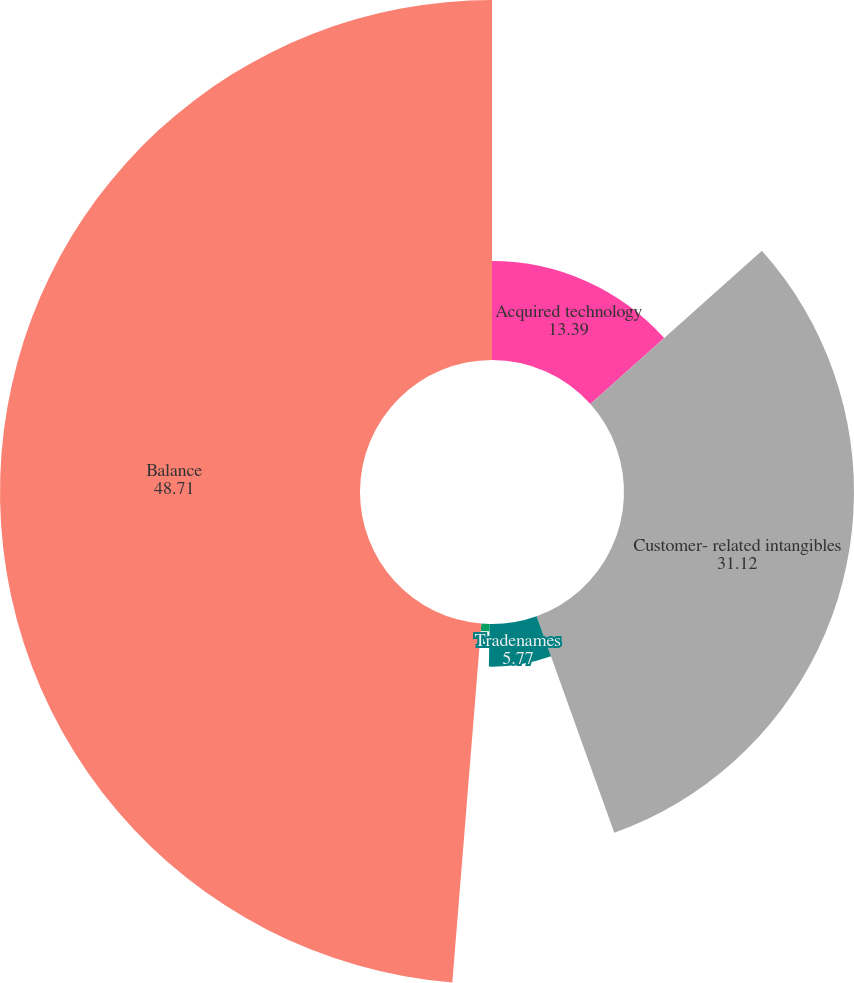Convert chart to OTSL. <chart><loc_0><loc_0><loc_500><loc_500><pie_chart><fcel>Acquired technology<fcel>Customer- related intangibles<fcel>Tradenames<fcel>Other<fcel>Balance<nl><fcel>13.39%<fcel>31.12%<fcel>5.77%<fcel>1.0%<fcel>48.71%<nl></chart> 